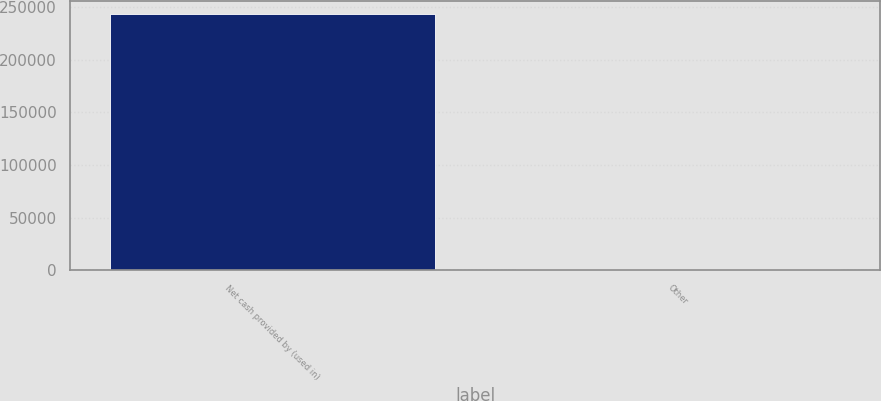Convert chart to OTSL. <chart><loc_0><loc_0><loc_500><loc_500><bar_chart><fcel>Net cash provided by (used in)<fcel>Other<nl><fcel>243379<fcel>789<nl></chart> 